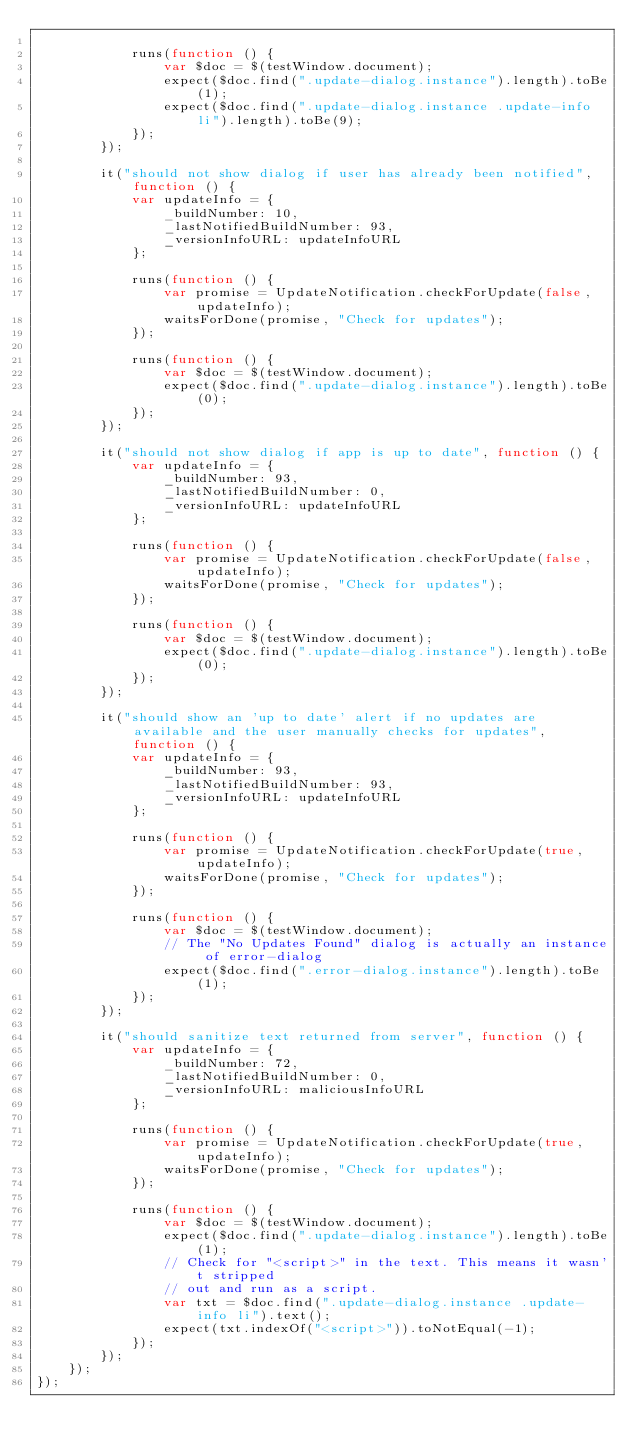Convert code to text. <code><loc_0><loc_0><loc_500><loc_500><_JavaScript_>            
            runs(function () {
                var $doc = $(testWindow.document);
                expect($doc.find(".update-dialog.instance").length).toBe(1);
                expect($doc.find(".update-dialog.instance .update-info li").length).toBe(9);
            });
        });
        
        it("should not show dialog if user has already been notified", function () {
            var updateInfo = {
                _buildNumber: 10,
                _lastNotifiedBuildNumber: 93,
                _versionInfoURL: updateInfoURL
            };
            
            runs(function () {
                var promise = UpdateNotification.checkForUpdate(false, updateInfo);
                waitsForDone(promise, "Check for updates");
            });
            
            runs(function () {
                var $doc = $(testWindow.document);
                expect($doc.find(".update-dialog.instance").length).toBe(0);
            });
        });
        
        it("should not show dialog if app is up to date", function () {
            var updateInfo = {
                _buildNumber: 93,
                _lastNotifiedBuildNumber: 0,
                _versionInfoURL: updateInfoURL
            };
            
            runs(function () {
                var promise = UpdateNotification.checkForUpdate(false, updateInfo);
                waitsForDone(promise, "Check for updates");
            });
            
            runs(function () {
                var $doc = $(testWindow.document);
                expect($doc.find(".update-dialog.instance").length).toBe(0);
            });
        });
        
        it("should show an 'up to date' alert if no updates are available and the user manually checks for updates", function () {
            var updateInfo = {
                _buildNumber: 93,
                _lastNotifiedBuildNumber: 93,
                _versionInfoURL: updateInfoURL
            };
            
            runs(function () {
                var promise = UpdateNotification.checkForUpdate(true, updateInfo);
                waitsForDone(promise, "Check for updates");
            });
            
            runs(function () {
                var $doc = $(testWindow.document);
                // The "No Updates Found" dialog is actually an instance of error-dialog
                expect($doc.find(".error-dialog.instance").length).toBe(1);
            });
        });
        
        it("should sanitize text returned from server", function () {
            var updateInfo = {
                _buildNumber: 72,
                _lastNotifiedBuildNumber: 0,
                _versionInfoURL: maliciousInfoURL
            };
            
            runs(function () {
                var promise = UpdateNotification.checkForUpdate(true, updateInfo);
                waitsForDone(promise, "Check for updates");
            });
            
            runs(function () {
                var $doc = $(testWindow.document);
                expect($doc.find(".update-dialog.instance").length).toBe(1);
                // Check for "<script>" in the text. This means it wasn't stripped
                // out and run as a script.
                var txt = $doc.find(".update-dialog.instance .update-info li").text();
                expect(txt.indexOf("<script>")).toNotEqual(-1);
            });
        });
    });
});
</code> 